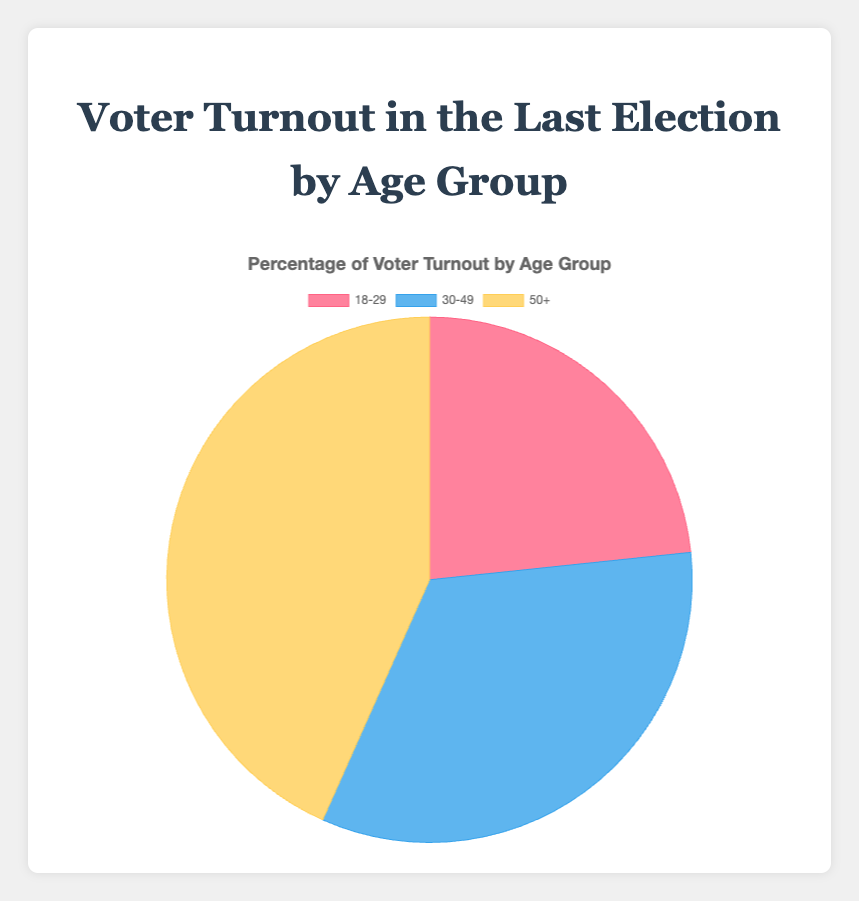What percentage of the total voter turnout does the 18-29 age group represent? To find the percentage, we directly refer to the data in the figure where the 18-29 age group is shown to have a 35% voter turnout.
Answer: 35% Which age group has the highest voter turnout? The figure clearly indicates the 50+ age group with the highest voter turnout at 65%.
Answer: 50+ What is the difference in voter turnout between the 30-49 age group and the 18-29 age group? According to the figure, the 30-49 age group has a 50% turnout and the 18-29 age group has 35%. Subtracting these gives 50 - 35 = 15%.
Answer: 15% What's the sum of voter turnout percentages for the 18-29 and 50+ age groups? Summing the percentages for the 18-29 (35%) and 50+ (65%) age groups yields 35 + 65 = 100%.
Answer: 100% Which age group is depicted in red on the pie chart? The visual attributes of the pie chart show the 18-29 age group in red.
Answer: 18-29 How much greater is the voter turnout percentage for the 50+ group compared to the 30-49 group? The 50+ age group has a 65% turnout, while the 30-49 age group has 50%. The difference is 65 - 50 = 15%.
Answer: 15% What is the average voter turnout percentage across all age groups? To find the average, sum all percentages: 35 + 50 + 65 = 150. Then divide by the number of age groups: 150 / 3 = 50%.
Answer: 50% If you combine the voter turnouts of the 18-29 and 30-49 age groups, is it more or less than the voter turnout of the 50+ age group? Adding 18-29 and 30-49 percentages gives 35 + 50 = 85%, which is more than the 50+ age group's 65%.
Answer: More Which age group is represented by the blue segment in the pie chart? The pie chart visually indicates the 30-49 age group with the blue segment.
Answer: 30-49 What is the percentage difference between the highest and lowest voter turnouts? The highest turnout is 65% (50+ age group) and the lowest is 35% (18-29 age group). The percentage difference is 65 - 35 = 30%.
Answer: 30% 